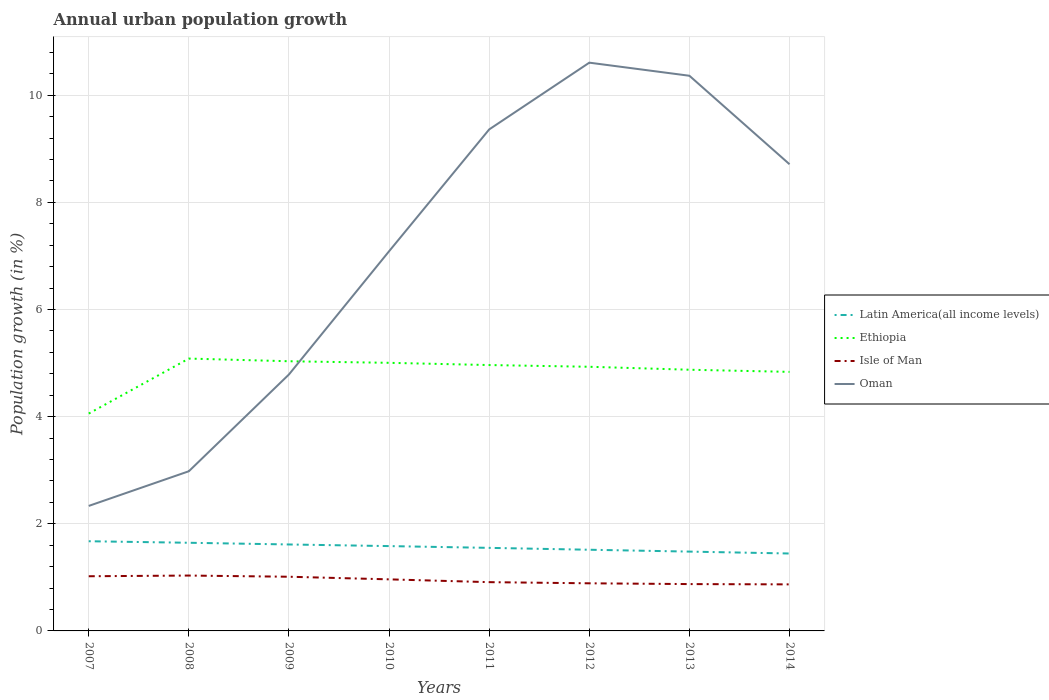Across all years, what is the maximum percentage of urban population growth in Oman?
Offer a very short reply. 2.33. In which year was the percentage of urban population growth in Oman maximum?
Provide a succinct answer. 2007. What is the total percentage of urban population growth in Oman in the graph?
Provide a succinct answer. -4.11. What is the difference between the highest and the second highest percentage of urban population growth in Ethiopia?
Your answer should be very brief. 1.03. What is the difference between the highest and the lowest percentage of urban population growth in Oman?
Offer a very short reply. 5. How many years are there in the graph?
Keep it short and to the point. 8. Are the values on the major ticks of Y-axis written in scientific E-notation?
Ensure brevity in your answer.  No. Does the graph contain any zero values?
Offer a terse response. No. Does the graph contain grids?
Provide a succinct answer. Yes. Where does the legend appear in the graph?
Offer a terse response. Center right. How many legend labels are there?
Give a very brief answer. 4. How are the legend labels stacked?
Give a very brief answer. Vertical. What is the title of the graph?
Ensure brevity in your answer.  Annual urban population growth. What is the label or title of the X-axis?
Your answer should be compact. Years. What is the label or title of the Y-axis?
Provide a succinct answer. Population growth (in %). What is the Population growth (in %) in Latin America(all income levels) in 2007?
Keep it short and to the point. 1.67. What is the Population growth (in %) in Ethiopia in 2007?
Your answer should be very brief. 4.06. What is the Population growth (in %) of Isle of Man in 2007?
Make the answer very short. 1.02. What is the Population growth (in %) of Oman in 2007?
Your response must be concise. 2.33. What is the Population growth (in %) in Latin America(all income levels) in 2008?
Make the answer very short. 1.65. What is the Population growth (in %) in Ethiopia in 2008?
Your answer should be compact. 5.08. What is the Population growth (in %) of Isle of Man in 2008?
Offer a very short reply. 1.03. What is the Population growth (in %) of Oman in 2008?
Offer a terse response. 2.98. What is the Population growth (in %) of Latin America(all income levels) in 2009?
Ensure brevity in your answer.  1.61. What is the Population growth (in %) of Ethiopia in 2009?
Provide a short and direct response. 5.03. What is the Population growth (in %) of Isle of Man in 2009?
Your answer should be very brief. 1.01. What is the Population growth (in %) in Oman in 2009?
Keep it short and to the point. 4.79. What is the Population growth (in %) of Latin America(all income levels) in 2010?
Provide a succinct answer. 1.58. What is the Population growth (in %) in Ethiopia in 2010?
Ensure brevity in your answer.  5. What is the Population growth (in %) of Isle of Man in 2010?
Provide a short and direct response. 0.96. What is the Population growth (in %) of Oman in 2010?
Keep it short and to the point. 7.09. What is the Population growth (in %) of Latin America(all income levels) in 2011?
Your response must be concise. 1.55. What is the Population growth (in %) of Ethiopia in 2011?
Your answer should be compact. 4.96. What is the Population growth (in %) of Isle of Man in 2011?
Your answer should be compact. 0.91. What is the Population growth (in %) in Oman in 2011?
Provide a succinct answer. 9.36. What is the Population growth (in %) in Latin America(all income levels) in 2012?
Your answer should be compact. 1.52. What is the Population growth (in %) of Ethiopia in 2012?
Provide a succinct answer. 4.93. What is the Population growth (in %) of Isle of Man in 2012?
Keep it short and to the point. 0.89. What is the Population growth (in %) in Oman in 2012?
Give a very brief answer. 10.61. What is the Population growth (in %) in Latin America(all income levels) in 2013?
Your response must be concise. 1.48. What is the Population growth (in %) of Ethiopia in 2013?
Ensure brevity in your answer.  4.88. What is the Population growth (in %) of Isle of Man in 2013?
Your answer should be compact. 0.87. What is the Population growth (in %) of Oman in 2013?
Keep it short and to the point. 10.36. What is the Population growth (in %) of Latin America(all income levels) in 2014?
Provide a short and direct response. 1.45. What is the Population growth (in %) in Ethiopia in 2014?
Provide a short and direct response. 4.84. What is the Population growth (in %) of Isle of Man in 2014?
Your answer should be compact. 0.87. What is the Population growth (in %) of Oman in 2014?
Keep it short and to the point. 8.71. Across all years, what is the maximum Population growth (in %) of Latin America(all income levels)?
Give a very brief answer. 1.67. Across all years, what is the maximum Population growth (in %) of Ethiopia?
Ensure brevity in your answer.  5.08. Across all years, what is the maximum Population growth (in %) in Isle of Man?
Provide a short and direct response. 1.03. Across all years, what is the maximum Population growth (in %) of Oman?
Offer a very short reply. 10.61. Across all years, what is the minimum Population growth (in %) in Latin America(all income levels)?
Your answer should be compact. 1.45. Across all years, what is the minimum Population growth (in %) of Ethiopia?
Your response must be concise. 4.06. Across all years, what is the minimum Population growth (in %) of Isle of Man?
Your answer should be compact. 0.87. Across all years, what is the minimum Population growth (in %) of Oman?
Offer a terse response. 2.33. What is the total Population growth (in %) in Latin America(all income levels) in the graph?
Your response must be concise. 12.51. What is the total Population growth (in %) in Ethiopia in the graph?
Your answer should be compact. 38.78. What is the total Population growth (in %) of Isle of Man in the graph?
Provide a succinct answer. 7.57. What is the total Population growth (in %) in Oman in the graph?
Keep it short and to the point. 56.23. What is the difference between the Population growth (in %) in Latin America(all income levels) in 2007 and that in 2008?
Your response must be concise. 0.03. What is the difference between the Population growth (in %) in Ethiopia in 2007 and that in 2008?
Give a very brief answer. -1.03. What is the difference between the Population growth (in %) in Isle of Man in 2007 and that in 2008?
Give a very brief answer. -0.01. What is the difference between the Population growth (in %) of Oman in 2007 and that in 2008?
Keep it short and to the point. -0.65. What is the difference between the Population growth (in %) in Latin America(all income levels) in 2007 and that in 2009?
Keep it short and to the point. 0.06. What is the difference between the Population growth (in %) of Ethiopia in 2007 and that in 2009?
Keep it short and to the point. -0.98. What is the difference between the Population growth (in %) in Isle of Man in 2007 and that in 2009?
Your answer should be very brief. 0.01. What is the difference between the Population growth (in %) in Oman in 2007 and that in 2009?
Provide a succinct answer. -2.45. What is the difference between the Population growth (in %) of Latin America(all income levels) in 2007 and that in 2010?
Your response must be concise. 0.09. What is the difference between the Population growth (in %) in Ethiopia in 2007 and that in 2010?
Your answer should be compact. -0.95. What is the difference between the Population growth (in %) of Isle of Man in 2007 and that in 2010?
Provide a short and direct response. 0.06. What is the difference between the Population growth (in %) of Oman in 2007 and that in 2010?
Your response must be concise. -4.75. What is the difference between the Population growth (in %) of Latin America(all income levels) in 2007 and that in 2011?
Offer a very short reply. 0.12. What is the difference between the Population growth (in %) in Ethiopia in 2007 and that in 2011?
Offer a terse response. -0.91. What is the difference between the Population growth (in %) of Isle of Man in 2007 and that in 2011?
Offer a very short reply. 0.11. What is the difference between the Population growth (in %) of Oman in 2007 and that in 2011?
Your answer should be compact. -7.03. What is the difference between the Population growth (in %) in Latin America(all income levels) in 2007 and that in 2012?
Ensure brevity in your answer.  0.16. What is the difference between the Population growth (in %) in Ethiopia in 2007 and that in 2012?
Offer a terse response. -0.87. What is the difference between the Population growth (in %) of Isle of Man in 2007 and that in 2012?
Keep it short and to the point. 0.13. What is the difference between the Population growth (in %) of Oman in 2007 and that in 2012?
Your response must be concise. -8.27. What is the difference between the Population growth (in %) of Latin America(all income levels) in 2007 and that in 2013?
Offer a terse response. 0.19. What is the difference between the Population growth (in %) in Ethiopia in 2007 and that in 2013?
Your answer should be very brief. -0.82. What is the difference between the Population growth (in %) in Isle of Man in 2007 and that in 2013?
Give a very brief answer. 0.15. What is the difference between the Population growth (in %) in Oman in 2007 and that in 2013?
Offer a very short reply. -8.03. What is the difference between the Population growth (in %) in Latin America(all income levels) in 2007 and that in 2014?
Make the answer very short. 0.23. What is the difference between the Population growth (in %) in Ethiopia in 2007 and that in 2014?
Offer a terse response. -0.78. What is the difference between the Population growth (in %) in Isle of Man in 2007 and that in 2014?
Make the answer very short. 0.15. What is the difference between the Population growth (in %) of Oman in 2007 and that in 2014?
Provide a short and direct response. -6.38. What is the difference between the Population growth (in %) in Latin America(all income levels) in 2008 and that in 2009?
Provide a short and direct response. 0.03. What is the difference between the Population growth (in %) of Isle of Man in 2008 and that in 2009?
Offer a terse response. 0.02. What is the difference between the Population growth (in %) in Oman in 2008 and that in 2009?
Ensure brevity in your answer.  -1.81. What is the difference between the Population growth (in %) in Latin America(all income levels) in 2008 and that in 2010?
Your answer should be compact. 0.06. What is the difference between the Population growth (in %) in Ethiopia in 2008 and that in 2010?
Provide a short and direct response. 0.08. What is the difference between the Population growth (in %) in Isle of Man in 2008 and that in 2010?
Provide a succinct answer. 0.07. What is the difference between the Population growth (in %) in Oman in 2008 and that in 2010?
Provide a short and direct response. -4.11. What is the difference between the Population growth (in %) of Latin America(all income levels) in 2008 and that in 2011?
Give a very brief answer. 0.1. What is the difference between the Population growth (in %) of Ethiopia in 2008 and that in 2011?
Your answer should be compact. 0.12. What is the difference between the Population growth (in %) of Isle of Man in 2008 and that in 2011?
Offer a very short reply. 0.12. What is the difference between the Population growth (in %) of Oman in 2008 and that in 2011?
Your answer should be compact. -6.38. What is the difference between the Population growth (in %) of Latin America(all income levels) in 2008 and that in 2012?
Your answer should be compact. 0.13. What is the difference between the Population growth (in %) in Ethiopia in 2008 and that in 2012?
Provide a short and direct response. 0.15. What is the difference between the Population growth (in %) of Isle of Man in 2008 and that in 2012?
Your response must be concise. 0.14. What is the difference between the Population growth (in %) of Oman in 2008 and that in 2012?
Offer a terse response. -7.63. What is the difference between the Population growth (in %) in Latin America(all income levels) in 2008 and that in 2013?
Your answer should be very brief. 0.16. What is the difference between the Population growth (in %) in Ethiopia in 2008 and that in 2013?
Offer a very short reply. 0.21. What is the difference between the Population growth (in %) of Isle of Man in 2008 and that in 2013?
Your answer should be very brief. 0.16. What is the difference between the Population growth (in %) in Oman in 2008 and that in 2013?
Ensure brevity in your answer.  -7.38. What is the difference between the Population growth (in %) in Latin America(all income levels) in 2008 and that in 2014?
Give a very brief answer. 0.2. What is the difference between the Population growth (in %) in Ethiopia in 2008 and that in 2014?
Make the answer very short. 0.25. What is the difference between the Population growth (in %) in Isle of Man in 2008 and that in 2014?
Give a very brief answer. 0.16. What is the difference between the Population growth (in %) of Oman in 2008 and that in 2014?
Offer a terse response. -5.73. What is the difference between the Population growth (in %) in Latin America(all income levels) in 2009 and that in 2010?
Keep it short and to the point. 0.03. What is the difference between the Population growth (in %) in Ethiopia in 2009 and that in 2010?
Offer a very short reply. 0.03. What is the difference between the Population growth (in %) of Isle of Man in 2009 and that in 2010?
Give a very brief answer. 0.05. What is the difference between the Population growth (in %) of Oman in 2009 and that in 2010?
Your answer should be compact. -2.3. What is the difference between the Population growth (in %) in Latin America(all income levels) in 2009 and that in 2011?
Make the answer very short. 0.06. What is the difference between the Population growth (in %) in Ethiopia in 2009 and that in 2011?
Provide a succinct answer. 0.07. What is the difference between the Population growth (in %) of Isle of Man in 2009 and that in 2011?
Ensure brevity in your answer.  0.1. What is the difference between the Population growth (in %) of Oman in 2009 and that in 2011?
Keep it short and to the point. -4.57. What is the difference between the Population growth (in %) in Latin America(all income levels) in 2009 and that in 2012?
Provide a short and direct response. 0.1. What is the difference between the Population growth (in %) in Ethiopia in 2009 and that in 2012?
Provide a short and direct response. 0.1. What is the difference between the Population growth (in %) of Isle of Man in 2009 and that in 2012?
Keep it short and to the point. 0.12. What is the difference between the Population growth (in %) in Oman in 2009 and that in 2012?
Ensure brevity in your answer.  -5.82. What is the difference between the Population growth (in %) of Latin America(all income levels) in 2009 and that in 2013?
Provide a short and direct response. 0.13. What is the difference between the Population growth (in %) of Ethiopia in 2009 and that in 2013?
Keep it short and to the point. 0.16. What is the difference between the Population growth (in %) of Isle of Man in 2009 and that in 2013?
Your response must be concise. 0.14. What is the difference between the Population growth (in %) in Oman in 2009 and that in 2013?
Your response must be concise. -5.58. What is the difference between the Population growth (in %) in Latin America(all income levels) in 2009 and that in 2014?
Ensure brevity in your answer.  0.17. What is the difference between the Population growth (in %) of Ethiopia in 2009 and that in 2014?
Your answer should be compact. 0.2. What is the difference between the Population growth (in %) in Isle of Man in 2009 and that in 2014?
Offer a very short reply. 0.14. What is the difference between the Population growth (in %) in Oman in 2009 and that in 2014?
Keep it short and to the point. -3.92. What is the difference between the Population growth (in %) in Latin America(all income levels) in 2010 and that in 2011?
Your answer should be very brief. 0.03. What is the difference between the Population growth (in %) in Ethiopia in 2010 and that in 2011?
Offer a terse response. 0.04. What is the difference between the Population growth (in %) in Isle of Man in 2010 and that in 2011?
Offer a very short reply. 0.05. What is the difference between the Population growth (in %) of Oman in 2010 and that in 2011?
Offer a terse response. -2.27. What is the difference between the Population growth (in %) in Latin America(all income levels) in 2010 and that in 2012?
Provide a short and direct response. 0.07. What is the difference between the Population growth (in %) of Ethiopia in 2010 and that in 2012?
Provide a succinct answer. 0.07. What is the difference between the Population growth (in %) of Isle of Man in 2010 and that in 2012?
Keep it short and to the point. 0.07. What is the difference between the Population growth (in %) in Oman in 2010 and that in 2012?
Provide a short and direct response. -3.52. What is the difference between the Population growth (in %) of Latin America(all income levels) in 2010 and that in 2013?
Give a very brief answer. 0.1. What is the difference between the Population growth (in %) in Ethiopia in 2010 and that in 2013?
Provide a succinct answer. 0.13. What is the difference between the Population growth (in %) of Isle of Man in 2010 and that in 2013?
Your response must be concise. 0.09. What is the difference between the Population growth (in %) in Oman in 2010 and that in 2013?
Offer a very short reply. -3.28. What is the difference between the Population growth (in %) in Latin America(all income levels) in 2010 and that in 2014?
Offer a very short reply. 0.14. What is the difference between the Population growth (in %) of Ethiopia in 2010 and that in 2014?
Offer a very short reply. 0.17. What is the difference between the Population growth (in %) of Isle of Man in 2010 and that in 2014?
Ensure brevity in your answer.  0.09. What is the difference between the Population growth (in %) of Oman in 2010 and that in 2014?
Make the answer very short. -1.62. What is the difference between the Population growth (in %) of Latin America(all income levels) in 2011 and that in 2012?
Give a very brief answer. 0.04. What is the difference between the Population growth (in %) in Ethiopia in 2011 and that in 2012?
Ensure brevity in your answer.  0.03. What is the difference between the Population growth (in %) of Isle of Man in 2011 and that in 2012?
Provide a short and direct response. 0.02. What is the difference between the Population growth (in %) of Oman in 2011 and that in 2012?
Provide a short and direct response. -1.25. What is the difference between the Population growth (in %) in Latin America(all income levels) in 2011 and that in 2013?
Make the answer very short. 0.07. What is the difference between the Population growth (in %) of Ethiopia in 2011 and that in 2013?
Your response must be concise. 0.09. What is the difference between the Population growth (in %) in Isle of Man in 2011 and that in 2013?
Ensure brevity in your answer.  0.04. What is the difference between the Population growth (in %) in Oman in 2011 and that in 2013?
Give a very brief answer. -1. What is the difference between the Population growth (in %) of Latin America(all income levels) in 2011 and that in 2014?
Ensure brevity in your answer.  0.11. What is the difference between the Population growth (in %) in Ethiopia in 2011 and that in 2014?
Provide a short and direct response. 0.13. What is the difference between the Population growth (in %) of Isle of Man in 2011 and that in 2014?
Your answer should be very brief. 0.04. What is the difference between the Population growth (in %) of Oman in 2011 and that in 2014?
Ensure brevity in your answer.  0.65. What is the difference between the Population growth (in %) in Latin America(all income levels) in 2012 and that in 2013?
Offer a very short reply. 0.03. What is the difference between the Population growth (in %) in Ethiopia in 2012 and that in 2013?
Offer a very short reply. 0.06. What is the difference between the Population growth (in %) of Isle of Man in 2012 and that in 2013?
Offer a very short reply. 0.01. What is the difference between the Population growth (in %) in Oman in 2012 and that in 2013?
Offer a very short reply. 0.24. What is the difference between the Population growth (in %) in Latin America(all income levels) in 2012 and that in 2014?
Your response must be concise. 0.07. What is the difference between the Population growth (in %) in Ethiopia in 2012 and that in 2014?
Offer a terse response. 0.1. What is the difference between the Population growth (in %) in Isle of Man in 2012 and that in 2014?
Ensure brevity in your answer.  0.02. What is the difference between the Population growth (in %) of Oman in 2012 and that in 2014?
Give a very brief answer. 1.9. What is the difference between the Population growth (in %) of Latin America(all income levels) in 2013 and that in 2014?
Ensure brevity in your answer.  0.04. What is the difference between the Population growth (in %) of Ethiopia in 2013 and that in 2014?
Offer a terse response. 0.04. What is the difference between the Population growth (in %) in Isle of Man in 2013 and that in 2014?
Your response must be concise. 0.01. What is the difference between the Population growth (in %) in Oman in 2013 and that in 2014?
Give a very brief answer. 1.65. What is the difference between the Population growth (in %) in Latin America(all income levels) in 2007 and the Population growth (in %) in Ethiopia in 2008?
Give a very brief answer. -3.41. What is the difference between the Population growth (in %) of Latin America(all income levels) in 2007 and the Population growth (in %) of Isle of Man in 2008?
Your answer should be very brief. 0.64. What is the difference between the Population growth (in %) in Latin America(all income levels) in 2007 and the Population growth (in %) in Oman in 2008?
Offer a terse response. -1.31. What is the difference between the Population growth (in %) in Ethiopia in 2007 and the Population growth (in %) in Isle of Man in 2008?
Your answer should be compact. 3.02. What is the difference between the Population growth (in %) in Ethiopia in 2007 and the Population growth (in %) in Oman in 2008?
Give a very brief answer. 1.08. What is the difference between the Population growth (in %) of Isle of Man in 2007 and the Population growth (in %) of Oman in 2008?
Offer a terse response. -1.96. What is the difference between the Population growth (in %) in Latin America(all income levels) in 2007 and the Population growth (in %) in Ethiopia in 2009?
Your response must be concise. -3.36. What is the difference between the Population growth (in %) of Latin America(all income levels) in 2007 and the Population growth (in %) of Isle of Man in 2009?
Give a very brief answer. 0.66. What is the difference between the Population growth (in %) in Latin America(all income levels) in 2007 and the Population growth (in %) in Oman in 2009?
Your answer should be compact. -3.11. What is the difference between the Population growth (in %) of Ethiopia in 2007 and the Population growth (in %) of Isle of Man in 2009?
Provide a succinct answer. 3.05. What is the difference between the Population growth (in %) of Ethiopia in 2007 and the Population growth (in %) of Oman in 2009?
Offer a very short reply. -0.73. What is the difference between the Population growth (in %) of Isle of Man in 2007 and the Population growth (in %) of Oman in 2009?
Your answer should be very brief. -3.77. What is the difference between the Population growth (in %) in Latin America(all income levels) in 2007 and the Population growth (in %) in Ethiopia in 2010?
Keep it short and to the point. -3.33. What is the difference between the Population growth (in %) in Latin America(all income levels) in 2007 and the Population growth (in %) in Isle of Man in 2010?
Your response must be concise. 0.71. What is the difference between the Population growth (in %) in Latin America(all income levels) in 2007 and the Population growth (in %) in Oman in 2010?
Offer a terse response. -5.41. What is the difference between the Population growth (in %) in Ethiopia in 2007 and the Population growth (in %) in Isle of Man in 2010?
Provide a short and direct response. 3.09. What is the difference between the Population growth (in %) in Ethiopia in 2007 and the Population growth (in %) in Oman in 2010?
Your answer should be very brief. -3.03. What is the difference between the Population growth (in %) of Isle of Man in 2007 and the Population growth (in %) of Oman in 2010?
Make the answer very short. -6.07. What is the difference between the Population growth (in %) of Latin America(all income levels) in 2007 and the Population growth (in %) of Ethiopia in 2011?
Offer a terse response. -3.29. What is the difference between the Population growth (in %) in Latin America(all income levels) in 2007 and the Population growth (in %) in Isle of Man in 2011?
Your answer should be very brief. 0.76. What is the difference between the Population growth (in %) in Latin America(all income levels) in 2007 and the Population growth (in %) in Oman in 2011?
Provide a short and direct response. -7.69. What is the difference between the Population growth (in %) of Ethiopia in 2007 and the Population growth (in %) of Isle of Man in 2011?
Your response must be concise. 3.15. What is the difference between the Population growth (in %) in Ethiopia in 2007 and the Population growth (in %) in Oman in 2011?
Keep it short and to the point. -5.3. What is the difference between the Population growth (in %) in Isle of Man in 2007 and the Population growth (in %) in Oman in 2011?
Your response must be concise. -8.34. What is the difference between the Population growth (in %) of Latin America(all income levels) in 2007 and the Population growth (in %) of Ethiopia in 2012?
Provide a short and direct response. -3.26. What is the difference between the Population growth (in %) in Latin America(all income levels) in 2007 and the Population growth (in %) in Isle of Man in 2012?
Offer a terse response. 0.79. What is the difference between the Population growth (in %) of Latin America(all income levels) in 2007 and the Population growth (in %) of Oman in 2012?
Give a very brief answer. -8.93. What is the difference between the Population growth (in %) of Ethiopia in 2007 and the Population growth (in %) of Isle of Man in 2012?
Offer a very short reply. 3.17. What is the difference between the Population growth (in %) of Ethiopia in 2007 and the Population growth (in %) of Oman in 2012?
Offer a terse response. -6.55. What is the difference between the Population growth (in %) of Isle of Man in 2007 and the Population growth (in %) of Oman in 2012?
Provide a short and direct response. -9.59. What is the difference between the Population growth (in %) of Latin America(all income levels) in 2007 and the Population growth (in %) of Ethiopia in 2013?
Offer a terse response. -3.2. What is the difference between the Population growth (in %) in Latin America(all income levels) in 2007 and the Population growth (in %) in Isle of Man in 2013?
Keep it short and to the point. 0.8. What is the difference between the Population growth (in %) of Latin America(all income levels) in 2007 and the Population growth (in %) of Oman in 2013?
Your answer should be compact. -8.69. What is the difference between the Population growth (in %) of Ethiopia in 2007 and the Population growth (in %) of Isle of Man in 2013?
Make the answer very short. 3.18. What is the difference between the Population growth (in %) of Ethiopia in 2007 and the Population growth (in %) of Oman in 2013?
Make the answer very short. -6.31. What is the difference between the Population growth (in %) in Isle of Man in 2007 and the Population growth (in %) in Oman in 2013?
Provide a succinct answer. -9.34. What is the difference between the Population growth (in %) of Latin America(all income levels) in 2007 and the Population growth (in %) of Ethiopia in 2014?
Ensure brevity in your answer.  -3.16. What is the difference between the Population growth (in %) of Latin America(all income levels) in 2007 and the Population growth (in %) of Isle of Man in 2014?
Your answer should be compact. 0.81. What is the difference between the Population growth (in %) of Latin America(all income levels) in 2007 and the Population growth (in %) of Oman in 2014?
Provide a short and direct response. -7.04. What is the difference between the Population growth (in %) of Ethiopia in 2007 and the Population growth (in %) of Isle of Man in 2014?
Give a very brief answer. 3.19. What is the difference between the Population growth (in %) of Ethiopia in 2007 and the Population growth (in %) of Oman in 2014?
Offer a very short reply. -4.65. What is the difference between the Population growth (in %) of Isle of Man in 2007 and the Population growth (in %) of Oman in 2014?
Provide a short and direct response. -7.69. What is the difference between the Population growth (in %) of Latin America(all income levels) in 2008 and the Population growth (in %) of Ethiopia in 2009?
Ensure brevity in your answer.  -3.39. What is the difference between the Population growth (in %) of Latin America(all income levels) in 2008 and the Population growth (in %) of Isle of Man in 2009?
Make the answer very short. 0.63. What is the difference between the Population growth (in %) in Latin America(all income levels) in 2008 and the Population growth (in %) in Oman in 2009?
Ensure brevity in your answer.  -3.14. What is the difference between the Population growth (in %) of Ethiopia in 2008 and the Population growth (in %) of Isle of Man in 2009?
Your answer should be very brief. 4.07. What is the difference between the Population growth (in %) of Ethiopia in 2008 and the Population growth (in %) of Oman in 2009?
Make the answer very short. 0.3. What is the difference between the Population growth (in %) in Isle of Man in 2008 and the Population growth (in %) in Oman in 2009?
Keep it short and to the point. -3.75. What is the difference between the Population growth (in %) of Latin America(all income levels) in 2008 and the Population growth (in %) of Ethiopia in 2010?
Keep it short and to the point. -3.36. What is the difference between the Population growth (in %) of Latin America(all income levels) in 2008 and the Population growth (in %) of Isle of Man in 2010?
Keep it short and to the point. 0.68. What is the difference between the Population growth (in %) of Latin America(all income levels) in 2008 and the Population growth (in %) of Oman in 2010?
Keep it short and to the point. -5.44. What is the difference between the Population growth (in %) in Ethiopia in 2008 and the Population growth (in %) in Isle of Man in 2010?
Keep it short and to the point. 4.12. What is the difference between the Population growth (in %) in Ethiopia in 2008 and the Population growth (in %) in Oman in 2010?
Give a very brief answer. -2. What is the difference between the Population growth (in %) in Isle of Man in 2008 and the Population growth (in %) in Oman in 2010?
Offer a terse response. -6.05. What is the difference between the Population growth (in %) of Latin America(all income levels) in 2008 and the Population growth (in %) of Ethiopia in 2011?
Offer a terse response. -3.32. What is the difference between the Population growth (in %) in Latin America(all income levels) in 2008 and the Population growth (in %) in Isle of Man in 2011?
Ensure brevity in your answer.  0.74. What is the difference between the Population growth (in %) in Latin America(all income levels) in 2008 and the Population growth (in %) in Oman in 2011?
Provide a short and direct response. -7.72. What is the difference between the Population growth (in %) of Ethiopia in 2008 and the Population growth (in %) of Isle of Man in 2011?
Offer a terse response. 4.17. What is the difference between the Population growth (in %) of Ethiopia in 2008 and the Population growth (in %) of Oman in 2011?
Keep it short and to the point. -4.28. What is the difference between the Population growth (in %) of Isle of Man in 2008 and the Population growth (in %) of Oman in 2011?
Offer a terse response. -8.33. What is the difference between the Population growth (in %) of Latin America(all income levels) in 2008 and the Population growth (in %) of Ethiopia in 2012?
Offer a terse response. -3.29. What is the difference between the Population growth (in %) in Latin America(all income levels) in 2008 and the Population growth (in %) in Isle of Man in 2012?
Make the answer very short. 0.76. What is the difference between the Population growth (in %) of Latin America(all income levels) in 2008 and the Population growth (in %) of Oman in 2012?
Offer a very short reply. -8.96. What is the difference between the Population growth (in %) of Ethiopia in 2008 and the Population growth (in %) of Isle of Man in 2012?
Offer a very short reply. 4.2. What is the difference between the Population growth (in %) in Ethiopia in 2008 and the Population growth (in %) in Oman in 2012?
Offer a terse response. -5.52. What is the difference between the Population growth (in %) of Isle of Man in 2008 and the Population growth (in %) of Oman in 2012?
Ensure brevity in your answer.  -9.57. What is the difference between the Population growth (in %) of Latin America(all income levels) in 2008 and the Population growth (in %) of Ethiopia in 2013?
Your answer should be compact. -3.23. What is the difference between the Population growth (in %) in Latin America(all income levels) in 2008 and the Population growth (in %) in Isle of Man in 2013?
Make the answer very short. 0.77. What is the difference between the Population growth (in %) of Latin America(all income levels) in 2008 and the Population growth (in %) of Oman in 2013?
Provide a short and direct response. -8.72. What is the difference between the Population growth (in %) of Ethiopia in 2008 and the Population growth (in %) of Isle of Man in 2013?
Give a very brief answer. 4.21. What is the difference between the Population growth (in %) of Ethiopia in 2008 and the Population growth (in %) of Oman in 2013?
Offer a terse response. -5.28. What is the difference between the Population growth (in %) in Isle of Man in 2008 and the Population growth (in %) in Oman in 2013?
Offer a very short reply. -9.33. What is the difference between the Population growth (in %) of Latin America(all income levels) in 2008 and the Population growth (in %) of Ethiopia in 2014?
Your answer should be compact. -3.19. What is the difference between the Population growth (in %) in Latin America(all income levels) in 2008 and the Population growth (in %) in Isle of Man in 2014?
Your answer should be very brief. 0.78. What is the difference between the Population growth (in %) of Latin America(all income levels) in 2008 and the Population growth (in %) of Oman in 2014?
Make the answer very short. -7.07. What is the difference between the Population growth (in %) of Ethiopia in 2008 and the Population growth (in %) of Isle of Man in 2014?
Offer a very short reply. 4.21. What is the difference between the Population growth (in %) in Ethiopia in 2008 and the Population growth (in %) in Oman in 2014?
Provide a short and direct response. -3.63. What is the difference between the Population growth (in %) of Isle of Man in 2008 and the Population growth (in %) of Oman in 2014?
Keep it short and to the point. -7.68. What is the difference between the Population growth (in %) in Latin America(all income levels) in 2009 and the Population growth (in %) in Ethiopia in 2010?
Your response must be concise. -3.39. What is the difference between the Population growth (in %) in Latin America(all income levels) in 2009 and the Population growth (in %) in Isle of Man in 2010?
Provide a short and direct response. 0.65. What is the difference between the Population growth (in %) in Latin America(all income levels) in 2009 and the Population growth (in %) in Oman in 2010?
Your answer should be compact. -5.47. What is the difference between the Population growth (in %) of Ethiopia in 2009 and the Population growth (in %) of Isle of Man in 2010?
Offer a terse response. 4.07. What is the difference between the Population growth (in %) in Ethiopia in 2009 and the Population growth (in %) in Oman in 2010?
Offer a very short reply. -2.05. What is the difference between the Population growth (in %) in Isle of Man in 2009 and the Population growth (in %) in Oman in 2010?
Offer a very short reply. -6.08. What is the difference between the Population growth (in %) of Latin America(all income levels) in 2009 and the Population growth (in %) of Ethiopia in 2011?
Give a very brief answer. -3.35. What is the difference between the Population growth (in %) in Latin America(all income levels) in 2009 and the Population growth (in %) in Isle of Man in 2011?
Provide a short and direct response. 0.7. What is the difference between the Population growth (in %) in Latin America(all income levels) in 2009 and the Population growth (in %) in Oman in 2011?
Your answer should be very brief. -7.75. What is the difference between the Population growth (in %) in Ethiopia in 2009 and the Population growth (in %) in Isle of Man in 2011?
Offer a terse response. 4.12. What is the difference between the Population growth (in %) of Ethiopia in 2009 and the Population growth (in %) of Oman in 2011?
Ensure brevity in your answer.  -4.33. What is the difference between the Population growth (in %) of Isle of Man in 2009 and the Population growth (in %) of Oman in 2011?
Provide a short and direct response. -8.35. What is the difference between the Population growth (in %) of Latin America(all income levels) in 2009 and the Population growth (in %) of Ethiopia in 2012?
Your answer should be very brief. -3.32. What is the difference between the Population growth (in %) in Latin America(all income levels) in 2009 and the Population growth (in %) in Isle of Man in 2012?
Ensure brevity in your answer.  0.73. What is the difference between the Population growth (in %) in Latin America(all income levels) in 2009 and the Population growth (in %) in Oman in 2012?
Ensure brevity in your answer.  -8.99. What is the difference between the Population growth (in %) in Ethiopia in 2009 and the Population growth (in %) in Isle of Man in 2012?
Provide a short and direct response. 4.15. What is the difference between the Population growth (in %) of Ethiopia in 2009 and the Population growth (in %) of Oman in 2012?
Provide a succinct answer. -5.57. What is the difference between the Population growth (in %) of Isle of Man in 2009 and the Population growth (in %) of Oman in 2012?
Your answer should be very brief. -9.6. What is the difference between the Population growth (in %) in Latin America(all income levels) in 2009 and the Population growth (in %) in Ethiopia in 2013?
Ensure brevity in your answer.  -3.26. What is the difference between the Population growth (in %) of Latin America(all income levels) in 2009 and the Population growth (in %) of Isle of Man in 2013?
Offer a terse response. 0.74. What is the difference between the Population growth (in %) of Latin America(all income levels) in 2009 and the Population growth (in %) of Oman in 2013?
Provide a short and direct response. -8.75. What is the difference between the Population growth (in %) in Ethiopia in 2009 and the Population growth (in %) in Isle of Man in 2013?
Ensure brevity in your answer.  4.16. What is the difference between the Population growth (in %) of Ethiopia in 2009 and the Population growth (in %) of Oman in 2013?
Your answer should be very brief. -5.33. What is the difference between the Population growth (in %) in Isle of Man in 2009 and the Population growth (in %) in Oman in 2013?
Offer a very short reply. -9.35. What is the difference between the Population growth (in %) in Latin America(all income levels) in 2009 and the Population growth (in %) in Ethiopia in 2014?
Give a very brief answer. -3.22. What is the difference between the Population growth (in %) of Latin America(all income levels) in 2009 and the Population growth (in %) of Isle of Man in 2014?
Give a very brief answer. 0.74. What is the difference between the Population growth (in %) in Latin America(all income levels) in 2009 and the Population growth (in %) in Oman in 2014?
Your answer should be very brief. -7.1. What is the difference between the Population growth (in %) in Ethiopia in 2009 and the Population growth (in %) in Isle of Man in 2014?
Offer a terse response. 4.17. What is the difference between the Population growth (in %) in Ethiopia in 2009 and the Population growth (in %) in Oman in 2014?
Keep it short and to the point. -3.68. What is the difference between the Population growth (in %) of Isle of Man in 2009 and the Population growth (in %) of Oman in 2014?
Offer a very short reply. -7.7. What is the difference between the Population growth (in %) in Latin America(all income levels) in 2010 and the Population growth (in %) in Ethiopia in 2011?
Provide a short and direct response. -3.38. What is the difference between the Population growth (in %) in Latin America(all income levels) in 2010 and the Population growth (in %) in Isle of Man in 2011?
Your response must be concise. 0.67. What is the difference between the Population growth (in %) in Latin America(all income levels) in 2010 and the Population growth (in %) in Oman in 2011?
Provide a short and direct response. -7.78. What is the difference between the Population growth (in %) in Ethiopia in 2010 and the Population growth (in %) in Isle of Man in 2011?
Provide a succinct answer. 4.09. What is the difference between the Population growth (in %) of Ethiopia in 2010 and the Population growth (in %) of Oman in 2011?
Provide a short and direct response. -4.36. What is the difference between the Population growth (in %) in Isle of Man in 2010 and the Population growth (in %) in Oman in 2011?
Your answer should be very brief. -8.4. What is the difference between the Population growth (in %) in Latin America(all income levels) in 2010 and the Population growth (in %) in Ethiopia in 2012?
Provide a short and direct response. -3.35. What is the difference between the Population growth (in %) of Latin America(all income levels) in 2010 and the Population growth (in %) of Isle of Man in 2012?
Your answer should be very brief. 0.69. What is the difference between the Population growth (in %) of Latin America(all income levels) in 2010 and the Population growth (in %) of Oman in 2012?
Provide a short and direct response. -9.02. What is the difference between the Population growth (in %) in Ethiopia in 2010 and the Population growth (in %) in Isle of Man in 2012?
Provide a short and direct response. 4.12. What is the difference between the Population growth (in %) of Ethiopia in 2010 and the Population growth (in %) of Oman in 2012?
Make the answer very short. -5.6. What is the difference between the Population growth (in %) in Isle of Man in 2010 and the Population growth (in %) in Oman in 2012?
Make the answer very short. -9.64. What is the difference between the Population growth (in %) of Latin America(all income levels) in 2010 and the Population growth (in %) of Ethiopia in 2013?
Ensure brevity in your answer.  -3.29. What is the difference between the Population growth (in %) in Latin America(all income levels) in 2010 and the Population growth (in %) in Isle of Man in 2013?
Keep it short and to the point. 0.71. What is the difference between the Population growth (in %) of Latin America(all income levels) in 2010 and the Population growth (in %) of Oman in 2013?
Provide a succinct answer. -8.78. What is the difference between the Population growth (in %) of Ethiopia in 2010 and the Population growth (in %) of Isle of Man in 2013?
Your response must be concise. 4.13. What is the difference between the Population growth (in %) in Ethiopia in 2010 and the Population growth (in %) in Oman in 2013?
Your answer should be very brief. -5.36. What is the difference between the Population growth (in %) in Isle of Man in 2010 and the Population growth (in %) in Oman in 2013?
Your response must be concise. -9.4. What is the difference between the Population growth (in %) in Latin America(all income levels) in 2010 and the Population growth (in %) in Ethiopia in 2014?
Offer a terse response. -3.25. What is the difference between the Population growth (in %) of Latin America(all income levels) in 2010 and the Population growth (in %) of Isle of Man in 2014?
Make the answer very short. 0.71. What is the difference between the Population growth (in %) of Latin America(all income levels) in 2010 and the Population growth (in %) of Oman in 2014?
Provide a succinct answer. -7.13. What is the difference between the Population growth (in %) in Ethiopia in 2010 and the Population growth (in %) in Isle of Man in 2014?
Ensure brevity in your answer.  4.14. What is the difference between the Population growth (in %) of Ethiopia in 2010 and the Population growth (in %) of Oman in 2014?
Make the answer very short. -3.71. What is the difference between the Population growth (in %) of Isle of Man in 2010 and the Population growth (in %) of Oman in 2014?
Keep it short and to the point. -7.75. What is the difference between the Population growth (in %) in Latin America(all income levels) in 2011 and the Population growth (in %) in Ethiopia in 2012?
Provide a succinct answer. -3.38. What is the difference between the Population growth (in %) of Latin America(all income levels) in 2011 and the Population growth (in %) of Isle of Man in 2012?
Offer a very short reply. 0.66. What is the difference between the Population growth (in %) of Latin America(all income levels) in 2011 and the Population growth (in %) of Oman in 2012?
Your answer should be compact. -9.06. What is the difference between the Population growth (in %) in Ethiopia in 2011 and the Population growth (in %) in Isle of Man in 2012?
Provide a succinct answer. 4.07. What is the difference between the Population growth (in %) in Ethiopia in 2011 and the Population growth (in %) in Oman in 2012?
Make the answer very short. -5.64. What is the difference between the Population growth (in %) of Isle of Man in 2011 and the Population growth (in %) of Oman in 2012?
Your response must be concise. -9.7. What is the difference between the Population growth (in %) of Latin America(all income levels) in 2011 and the Population growth (in %) of Ethiopia in 2013?
Your response must be concise. -3.33. What is the difference between the Population growth (in %) of Latin America(all income levels) in 2011 and the Population growth (in %) of Isle of Man in 2013?
Your response must be concise. 0.68. What is the difference between the Population growth (in %) of Latin America(all income levels) in 2011 and the Population growth (in %) of Oman in 2013?
Make the answer very short. -8.81. What is the difference between the Population growth (in %) of Ethiopia in 2011 and the Population growth (in %) of Isle of Man in 2013?
Provide a short and direct response. 4.09. What is the difference between the Population growth (in %) of Isle of Man in 2011 and the Population growth (in %) of Oman in 2013?
Your answer should be very brief. -9.45. What is the difference between the Population growth (in %) of Latin America(all income levels) in 2011 and the Population growth (in %) of Ethiopia in 2014?
Offer a very short reply. -3.29. What is the difference between the Population growth (in %) of Latin America(all income levels) in 2011 and the Population growth (in %) of Isle of Man in 2014?
Ensure brevity in your answer.  0.68. What is the difference between the Population growth (in %) in Latin America(all income levels) in 2011 and the Population growth (in %) in Oman in 2014?
Provide a succinct answer. -7.16. What is the difference between the Population growth (in %) of Ethiopia in 2011 and the Population growth (in %) of Isle of Man in 2014?
Your response must be concise. 4.09. What is the difference between the Population growth (in %) in Ethiopia in 2011 and the Population growth (in %) in Oman in 2014?
Offer a terse response. -3.75. What is the difference between the Population growth (in %) of Isle of Man in 2011 and the Population growth (in %) of Oman in 2014?
Offer a very short reply. -7.8. What is the difference between the Population growth (in %) in Latin America(all income levels) in 2012 and the Population growth (in %) in Ethiopia in 2013?
Your answer should be very brief. -3.36. What is the difference between the Population growth (in %) in Latin America(all income levels) in 2012 and the Population growth (in %) in Isle of Man in 2013?
Ensure brevity in your answer.  0.64. What is the difference between the Population growth (in %) of Latin America(all income levels) in 2012 and the Population growth (in %) of Oman in 2013?
Provide a short and direct response. -8.85. What is the difference between the Population growth (in %) of Ethiopia in 2012 and the Population growth (in %) of Isle of Man in 2013?
Give a very brief answer. 4.06. What is the difference between the Population growth (in %) in Ethiopia in 2012 and the Population growth (in %) in Oman in 2013?
Provide a succinct answer. -5.43. What is the difference between the Population growth (in %) of Isle of Man in 2012 and the Population growth (in %) of Oman in 2013?
Your answer should be compact. -9.47. What is the difference between the Population growth (in %) in Latin America(all income levels) in 2012 and the Population growth (in %) in Ethiopia in 2014?
Keep it short and to the point. -3.32. What is the difference between the Population growth (in %) in Latin America(all income levels) in 2012 and the Population growth (in %) in Isle of Man in 2014?
Your answer should be very brief. 0.65. What is the difference between the Population growth (in %) in Latin America(all income levels) in 2012 and the Population growth (in %) in Oman in 2014?
Your response must be concise. -7.2. What is the difference between the Population growth (in %) in Ethiopia in 2012 and the Population growth (in %) in Isle of Man in 2014?
Provide a short and direct response. 4.06. What is the difference between the Population growth (in %) in Ethiopia in 2012 and the Population growth (in %) in Oman in 2014?
Provide a succinct answer. -3.78. What is the difference between the Population growth (in %) of Isle of Man in 2012 and the Population growth (in %) of Oman in 2014?
Give a very brief answer. -7.82. What is the difference between the Population growth (in %) of Latin America(all income levels) in 2013 and the Population growth (in %) of Ethiopia in 2014?
Offer a very short reply. -3.35. What is the difference between the Population growth (in %) in Latin America(all income levels) in 2013 and the Population growth (in %) in Isle of Man in 2014?
Offer a terse response. 0.61. What is the difference between the Population growth (in %) in Latin America(all income levels) in 2013 and the Population growth (in %) in Oman in 2014?
Provide a short and direct response. -7.23. What is the difference between the Population growth (in %) in Ethiopia in 2013 and the Population growth (in %) in Isle of Man in 2014?
Ensure brevity in your answer.  4.01. What is the difference between the Population growth (in %) in Ethiopia in 2013 and the Population growth (in %) in Oman in 2014?
Your answer should be very brief. -3.84. What is the difference between the Population growth (in %) of Isle of Man in 2013 and the Population growth (in %) of Oman in 2014?
Offer a terse response. -7.84. What is the average Population growth (in %) in Latin America(all income levels) per year?
Provide a succinct answer. 1.56. What is the average Population growth (in %) in Ethiopia per year?
Offer a terse response. 4.85. What is the average Population growth (in %) of Isle of Man per year?
Give a very brief answer. 0.95. What is the average Population growth (in %) of Oman per year?
Keep it short and to the point. 7.03. In the year 2007, what is the difference between the Population growth (in %) of Latin America(all income levels) and Population growth (in %) of Ethiopia?
Your answer should be compact. -2.38. In the year 2007, what is the difference between the Population growth (in %) of Latin America(all income levels) and Population growth (in %) of Isle of Man?
Ensure brevity in your answer.  0.65. In the year 2007, what is the difference between the Population growth (in %) of Latin America(all income levels) and Population growth (in %) of Oman?
Your answer should be very brief. -0.66. In the year 2007, what is the difference between the Population growth (in %) of Ethiopia and Population growth (in %) of Isle of Man?
Give a very brief answer. 3.04. In the year 2007, what is the difference between the Population growth (in %) of Ethiopia and Population growth (in %) of Oman?
Give a very brief answer. 1.72. In the year 2007, what is the difference between the Population growth (in %) of Isle of Man and Population growth (in %) of Oman?
Offer a terse response. -1.31. In the year 2008, what is the difference between the Population growth (in %) of Latin America(all income levels) and Population growth (in %) of Ethiopia?
Provide a succinct answer. -3.44. In the year 2008, what is the difference between the Population growth (in %) in Latin America(all income levels) and Population growth (in %) in Isle of Man?
Make the answer very short. 0.61. In the year 2008, what is the difference between the Population growth (in %) in Latin America(all income levels) and Population growth (in %) in Oman?
Keep it short and to the point. -1.34. In the year 2008, what is the difference between the Population growth (in %) of Ethiopia and Population growth (in %) of Isle of Man?
Keep it short and to the point. 4.05. In the year 2008, what is the difference between the Population growth (in %) of Ethiopia and Population growth (in %) of Oman?
Ensure brevity in your answer.  2.1. In the year 2008, what is the difference between the Population growth (in %) of Isle of Man and Population growth (in %) of Oman?
Give a very brief answer. -1.95. In the year 2009, what is the difference between the Population growth (in %) in Latin America(all income levels) and Population growth (in %) in Ethiopia?
Ensure brevity in your answer.  -3.42. In the year 2009, what is the difference between the Population growth (in %) of Latin America(all income levels) and Population growth (in %) of Isle of Man?
Keep it short and to the point. 0.6. In the year 2009, what is the difference between the Population growth (in %) in Latin America(all income levels) and Population growth (in %) in Oman?
Your answer should be compact. -3.17. In the year 2009, what is the difference between the Population growth (in %) in Ethiopia and Population growth (in %) in Isle of Man?
Offer a very short reply. 4.02. In the year 2009, what is the difference between the Population growth (in %) of Ethiopia and Population growth (in %) of Oman?
Offer a terse response. 0.25. In the year 2009, what is the difference between the Population growth (in %) of Isle of Man and Population growth (in %) of Oman?
Your response must be concise. -3.78. In the year 2010, what is the difference between the Population growth (in %) of Latin America(all income levels) and Population growth (in %) of Ethiopia?
Your response must be concise. -3.42. In the year 2010, what is the difference between the Population growth (in %) of Latin America(all income levels) and Population growth (in %) of Isle of Man?
Offer a terse response. 0.62. In the year 2010, what is the difference between the Population growth (in %) of Latin America(all income levels) and Population growth (in %) of Oman?
Give a very brief answer. -5.5. In the year 2010, what is the difference between the Population growth (in %) of Ethiopia and Population growth (in %) of Isle of Man?
Provide a short and direct response. 4.04. In the year 2010, what is the difference between the Population growth (in %) of Ethiopia and Population growth (in %) of Oman?
Offer a terse response. -2.08. In the year 2010, what is the difference between the Population growth (in %) of Isle of Man and Population growth (in %) of Oman?
Keep it short and to the point. -6.12. In the year 2011, what is the difference between the Population growth (in %) of Latin America(all income levels) and Population growth (in %) of Ethiopia?
Provide a succinct answer. -3.41. In the year 2011, what is the difference between the Population growth (in %) of Latin America(all income levels) and Population growth (in %) of Isle of Man?
Keep it short and to the point. 0.64. In the year 2011, what is the difference between the Population growth (in %) in Latin America(all income levels) and Population growth (in %) in Oman?
Provide a short and direct response. -7.81. In the year 2011, what is the difference between the Population growth (in %) in Ethiopia and Population growth (in %) in Isle of Man?
Your answer should be compact. 4.05. In the year 2011, what is the difference between the Population growth (in %) in Ethiopia and Population growth (in %) in Oman?
Give a very brief answer. -4.4. In the year 2011, what is the difference between the Population growth (in %) of Isle of Man and Population growth (in %) of Oman?
Provide a succinct answer. -8.45. In the year 2012, what is the difference between the Population growth (in %) of Latin America(all income levels) and Population growth (in %) of Ethiopia?
Your answer should be very brief. -3.42. In the year 2012, what is the difference between the Population growth (in %) in Latin America(all income levels) and Population growth (in %) in Isle of Man?
Give a very brief answer. 0.63. In the year 2012, what is the difference between the Population growth (in %) in Latin America(all income levels) and Population growth (in %) in Oman?
Offer a very short reply. -9.09. In the year 2012, what is the difference between the Population growth (in %) of Ethiopia and Population growth (in %) of Isle of Man?
Offer a very short reply. 4.04. In the year 2012, what is the difference between the Population growth (in %) in Ethiopia and Population growth (in %) in Oman?
Make the answer very short. -5.68. In the year 2012, what is the difference between the Population growth (in %) of Isle of Man and Population growth (in %) of Oman?
Keep it short and to the point. -9.72. In the year 2013, what is the difference between the Population growth (in %) of Latin America(all income levels) and Population growth (in %) of Ethiopia?
Your answer should be compact. -3.39. In the year 2013, what is the difference between the Population growth (in %) of Latin America(all income levels) and Population growth (in %) of Isle of Man?
Ensure brevity in your answer.  0.61. In the year 2013, what is the difference between the Population growth (in %) in Latin America(all income levels) and Population growth (in %) in Oman?
Your answer should be compact. -8.88. In the year 2013, what is the difference between the Population growth (in %) in Ethiopia and Population growth (in %) in Isle of Man?
Your response must be concise. 4. In the year 2013, what is the difference between the Population growth (in %) of Ethiopia and Population growth (in %) of Oman?
Offer a very short reply. -5.49. In the year 2013, what is the difference between the Population growth (in %) in Isle of Man and Population growth (in %) in Oman?
Provide a succinct answer. -9.49. In the year 2014, what is the difference between the Population growth (in %) of Latin America(all income levels) and Population growth (in %) of Ethiopia?
Ensure brevity in your answer.  -3.39. In the year 2014, what is the difference between the Population growth (in %) of Latin America(all income levels) and Population growth (in %) of Isle of Man?
Ensure brevity in your answer.  0.58. In the year 2014, what is the difference between the Population growth (in %) in Latin America(all income levels) and Population growth (in %) in Oman?
Provide a succinct answer. -7.27. In the year 2014, what is the difference between the Population growth (in %) in Ethiopia and Population growth (in %) in Isle of Man?
Provide a succinct answer. 3.97. In the year 2014, what is the difference between the Population growth (in %) of Ethiopia and Population growth (in %) of Oman?
Make the answer very short. -3.88. In the year 2014, what is the difference between the Population growth (in %) in Isle of Man and Population growth (in %) in Oman?
Offer a terse response. -7.84. What is the ratio of the Population growth (in %) in Latin America(all income levels) in 2007 to that in 2008?
Keep it short and to the point. 1.02. What is the ratio of the Population growth (in %) in Ethiopia in 2007 to that in 2008?
Give a very brief answer. 0.8. What is the ratio of the Population growth (in %) of Isle of Man in 2007 to that in 2008?
Provide a short and direct response. 0.99. What is the ratio of the Population growth (in %) in Oman in 2007 to that in 2008?
Offer a very short reply. 0.78. What is the ratio of the Population growth (in %) of Latin America(all income levels) in 2007 to that in 2009?
Give a very brief answer. 1.04. What is the ratio of the Population growth (in %) in Ethiopia in 2007 to that in 2009?
Your answer should be very brief. 0.81. What is the ratio of the Population growth (in %) in Oman in 2007 to that in 2009?
Provide a short and direct response. 0.49. What is the ratio of the Population growth (in %) of Latin America(all income levels) in 2007 to that in 2010?
Keep it short and to the point. 1.06. What is the ratio of the Population growth (in %) in Ethiopia in 2007 to that in 2010?
Make the answer very short. 0.81. What is the ratio of the Population growth (in %) of Isle of Man in 2007 to that in 2010?
Ensure brevity in your answer.  1.06. What is the ratio of the Population growth (in %) of Oman in 2007 to that in 2010?
Give a very brief answer. 0.33. What is the ratio of the Population growth (in %) of Latin America(all income levels) in 2007 to that in 2011?
Your answer should be very brief. 1.08. What is the ratio of the Population growth (in %) of Ethiopia in 2007 to that in 2011?
Your answer should be compact. 0.82. What is the ratio of the Population growth (in %) of Isle of Man in 2007 to that in 2011?
Keep it short and to the point. 1.12. What is the ratio of the Population growth (in %) of Oman in 2007 to that in 2011?
Provide a short and direct response. 0.25. What is the ratio of the Population growth (in %) of Latin America(all income levels) in 2007 to that in 2012?
Offer a terse response. 1.1. What is the ratio of the Population growth (in %) of Ethiopia in 2007 to that in 2012?
Your answer should be very brief. 0.82. What is the ratio of the Population growth (in %) in Isle of Man in 2007 to that in 2012?
Your answer should be very brief. 1.15. What is the ratio of the Population growth (in %) in Oman in 2007 to that in 2012?
Provide a succinct answer. 0.22. What is the ratio of the Population growth (in %) in Latin America(all income levels) in 2007 to that in 2013?
Offer a terse response. 1.13. What is the ratio of the Population growth (in %) in Ethiopia in 2007 to that in 2013?
Your answer should be very brief. 0.83. What is the ratio of the Population growth (in %) of Isle of Man in 2007 to that in 2013?
Provide a succinct answer. 1.17. What is the ratio of the Population growth (in %) of Oman in 2007 to that in 2013?
Your answer should be very brief. 0.23. What is the ratio of the Population growth (in %) of Latin America(all income levels) in 2007 to that in 2014?
Ensure brevity in your answer.  1.16. What is the ratio of the Population growth (in %) of Ethiopia in 2007 to that in 2014?
Your answer should be very brief. 0.84. What is the ratio of the Population growth (in %) in Isle of Man in 2007 to that in 2014?
Provide a succinct answer. 1.17. What is the ratio of the Population growth (in %) in Oman in 2007 to that in 2014?
Offer a very short reply. 0.27. What is the ratio of the Population growth (in %) of Latin America(all income levels) in 2008 to that in 2009?
Make the answer very short. 1.02. What is the ratio of the Population growth (in %) of Ethiopia in 2008 to that in 2009?
Offer a very short reply. 1.01. What is the ratio of the Population growth (in %) of Isle of Man in 2008 to that in 2009?
Offer a terse response. 1.02. What is the ratio of the Population growth (in %) in Oman in 2008 to that in 2009?
Provide a succinct answer. 0.62. What is the ratio of the Population growth (in %) in Latin America(all income levels) in 2008 to that in 2010?
Keep it short and to the point. 1.04. What is the ratio of the Population growth (in %) of Ethiopia in 2008 to that in 2010?
Your answer should be compact. 1.02. What is the ratio of the Population growth (in %) in Isle of Man in 2008 to that in 2010?
Keep it short and to the point. 1.07. What is the ratio of the Population growth (in %) in Oman in 2008 to that in 2010?
Your response must be concise. 0.42. What is the ratio of the Population growth (in %) in Latin America(all income levels) in 2008 to that in 2011?
Your answer should be compact. 1.06. What is the ratio of the Population growth (in %) of Ethiopia in 2008 to that in 2011?
Your answer should be very brief. 1.02. What is the ratio of the Population growth (in %) of Isle of Man in 2008 to that in 2011?
Ensure brevity in your answer.  1.14. What is the ratio of the Population growth (in %) of Oman in 2008 to that in 2011?
Ensure brevity in your answer.  0.32. What is the ratio of the Population growth (in %) of Latin America(all income levels) in 2008 to that in 2012?
Make the answer very short. 1.09. What is the ratio of the Population growth (in %) in Ethiopia in 2008 to that in 2012?
Offer a terse response. 1.03. What is the ratio of the Population growth (in %) in Isle of Man in 2008 to that in 2012?
Provide a succinct answer. 1.16. What is the ratio of the Population growth (in %) in Oman in 2008 to that in 2012?
Offer a very short reply. 0.28. What is the ratio of the Population growth (in %) in Latin America(all income levels) in 2008 to that in 2013?
Provide a succinct answer. 1.11. What is the ratio of the Population growth (in %) in Ethiopia in 2008 to that in 2013?
Your answer should be very brief. 1.04. What is the ratio of the Population growth (in %) in Isle of Man in 2008 to that in 2013?
Your answer should be very brief. 1.18. What is the ratio of the Population growth (in %) in Oman in 2008 to that in 2013?
Your answer should be very brief. 0.29. What is the ratio of the Population growth (in %) of Latin America(all income levels) in 2008 to that in 2014?
Keep it short and to the point. 1.14. What is the ratio of the Population growth (in %) of Ethiopia in 2008 to that in 2014?
Keep it short and to the point. 1.05. What is the ratio of the Population growth (in %) of Isle of Man in 2008 to that in 2014?
Provide a succinct answer. 1.19. What is the ratio of the Population growth (in %) of Oman in 2008 to that in 2014?
Offer a very short reply. 0.34. What is the ratio of the Population growth (in %) in Latin America(all income levels) in 2009 to that in 2010?
Give a very brief answer. 1.02. What is the ratio of the Population growth (in %) of Ethiopia in 2009 to that in 2010?
Keep it short and to the point. 1.01. What is the ratio of the Population growth (in %) of Isle of Man in 2009 to that in 2010?
Your answer should be compact. 1.05. What is the ratio of the Population growth (in %) in Oman in 2009 to that in 2010?
Provide a short and direct response. 0.68. What is the ratio of the Population growth (in %) in Latin America(all income levels) in 2009 to that in 2011?
Ensure brevity in your answer.  1.04. What is the ratio of the Population growth (in %) in Ethiopia in 2009 to that in 2011?
Your response must be concise. 1.01. What is the ratio of the Population growth (in %) in Isle of Man in 2009 to that in 2011?
Your answer should be compact. 1.11. What is the ratio of the Population growth (in %) in Oman in 2009 to that in 2011?
Your response must be concise. 0.51. What is the ratio of the Population growth (in %) of Latin America(all income levels) in 2009 to that in 2012?
Your answer should be compact. 1.06. What is the ratio of the Population growth (in %) of Ethiopia in 2009 to that in 2012?
Provide a short and direct response. 1.02. What is the ratio of the Population growth (in %) of Isle of Man in 2009 to that in 2012?
Offer a very short reply. 1.14. What is the ratio of the Population growth (in %) in Oman in 2009 to that in 2012?
Your response must be concise. 0.45. What is the ratio of the Population growth (in %) of Latin America(all income levels) in 2009 to that in 2013?
Ensure brevity in your answer.  1.09. What is the ratio of the Population growth (in %) of Ethiopia in 2009 to that in 2013?
Your answer should be very brief. 1.03. What is the ratio of the Population growth (in %) in Isle of Man in 2009 to that in 2013?
Your answer should be very brief. 1.16. What is the ratio of the Population growth (in %) in Oman in 2009 to that in 2013?
Make the answer very short. 0.46. What is the ratio of the Population growth (in %) in Latin America(all income levels) in 2009 to that in 2014?
Offer a terse response. 1.12. What is the ratio of the Population growth (in %) of Ethiopia in 2009 to that in 2014?
Offer a very short reply. 1.04. What is the ratio of the Population growth (in %) in Isle of Man in 2009 to that in 2014?
Offer a very short reply. 1.16. What is the ratio of the Population growth (in %) in Oman in 2009 to that in 2014?
Keep it short and to the point. 0.55. What is the ratio of the Population growth (in %) in Latin America(all income levels) in 2010 to that in 2011?
Provide a short and direct response. 1.02. What is the ratio of the Population growth (in %) of Ethiopia in 2010 to that in 2011?
Give a very brief answer. 1.01. What is the ratio of the Population growth (in %) in Isle of Man in 2010 to that in 2011?
Keep it short and to the point. 1.06. What is the ratio of the Population growth (in %) of Oman in 2010 to that in 2011?
Your answer should be very brief. 0.76. What is the ratio of the Population growth (in %) of Latin America(all income levels) in 2010 to that in 2012?
Offer a terse response. 1.04. What is the ratio of the Population growth (in %) of Ethiopia in 2010 to that in 2012?
Make the answer very short. 1.01. What is the ratio of the Population growth (in %) of Isle of Man in 2010 to that in 2012?
Offer a terse response. 1.08. What is the ratio of the Population growth (in %) in Oman in 2010 to that in 2012?
Keep it short and to the point. 0.67. What is the ratio of the Population growth (in %) of Latin America(all income levels) in 2010 to that in 2013?
Give a very brief answer. 1.07. What is the ratio of the Population growth (in %) of Ethiopia in 2010 to that in 2013?
Your answer should be very brief. 1.03. What is the ratio of the Population growth (in %) in Isle of Man in 2010 to that in 2013?
Your response must be concise. 1.1. What is the ratio of the Population growth (in %) in Oman in 2010 to that in 2013?
Give a very brief answer. 0.68. What is the ratio of the Population growth (in %) of Latin America(all income levels) in 2010 to that in 2014?
Your answer should be compact. 1.1. What is the ratio of the Population growth (in %) of Ethiopia in 2010 to that in 2014?
Provide a succinct answer. 1.03. What is the ratio of the Population growth (in %) in Isle of Man in 2010 to that in 2014?
Your response must be concise. 1.11. What is the ratio of the Population growth (in %) of Oman in 2010 to that in 2014?
Offer a very short reply. 0.81. What is the ratio of the Population growth (in %) in Latin America(all income levels) in 2011 to that in 2012?
Make the answer very short. 1.02. What is the ratio of the Population growth (in %) of Ethiopia in 2011 to that in 2012?
Keep it short and to the point. 1.01. What is the ratio of the Population growth (in %) of Isle of Man in 2011 to that in 2012?
Your answer should be very brief. 1.02. What is the ratio of the Population growth (in %) in Oman in 2011 to that in 2012?
Your response must be concise. 0.88. What is the ratio of the Population growth (in %) of Latin America(all income levels) in 2011 to that in 2013?
Your response must be concise. 1.05. What is the ratio of the Population growth (in %) in Ethiopia in 2011 to that in 2013?
Your answer should be compact. 1.02. What is the ratio of the Population growth (in %) in Isle of Man in 2011 to that in 2013?
Your answer should be very brief. 1.04. What is the ratio of the Population growth (in %) in Oman in 2011 to that in 2013?
Provide a short and direct response. 0.9. What is the ratio of the Population growth (in %) of Latin America(all income levels) in 2011 to that in 2014?
Keep it short and to the point. 1.07. What is the ratio of the Population growth (in %) in Ethiopia in 2011 to that in 2014?
Your answer should be compact. 1.03. What is the ratio of the Population growth (in %) of Isle of Man in 2011 to that in 2014?
Your answer should be compact. 1.05. What is the ratio of the Population growth (in %) of Oman in 2011 to that in 2014?
Provide a succinct answer. 1.07. What is the ratio of the Population growth (in %) in Latin America(all income levels) in 2012 to that in 2013?
Keep it short and to the point. 1.02. What is the ratio of the Population growth (in %) in Ethiopia in 2012 to that in 2013?
Offer a very short reply. 1.01. What is the ratio of the Population growth (in %) in Isle of Man in 2012 to that in 2013?
Ensure brevity in your answer.  1.02. What is the ratio of the Population growth (in %) of Oman in 2012 to that in 2013?
Provide a succinct answer. 1.02. What is the ratio of the Population growth (in %) in Latin America(all income levels) in 2012 to that in 2014?
Your answer should be compact. 1.05. What is the ratio of the Population growth (in %) of Ethiopia in 2012 to that in 2014?
Offer a very short reply. 1.02. What is the ratio of the Population growth (in %) in Isle of Man in 2012 to that in 2014?
Give a very brief answer. 1.02. What is the ratio of the Population growth (in %) of Oman in 2012 to that in 2014?
Ensure brevity in your answer.  1.22. What is the ratio of the Population growth (in %) in Latin America(all income levels) in 2013 to that in 2014?
Offer a very short reply. 1.02. What is the ratio of the Population growth (in %) of Ethiopia in 2013 to that in 2014?
Offer a very short reply. 1.01. What is the ratio of the Population growth (in %) of Isle of Man in 2013 to that in 2014?
Your answer should be compact. 1.01. What is the ratio of the Population growth (in %) of Oman in 2013 to that in 2014?
Give a very brief answer. 1.19. What is the difference between the highest and the second highest Population growth (in %) of Latin America(all income levels)?
Keep it short and to the point. 0.03. What is the difference between the highest and the second highest Population growth (in %) in Ethiopia?
Provide a succinct answer. 0.05. What is the difference between the highest and the second highest Population growth (in %) in Isle of Man?
Your response must be concise. 0.01. What is the difference between the highest and the second highest Population growth (in %) of Oman?
Offer a terse response. 0.24. What is the difference between the highest and the lowest Population growth (in %) in Latin America(all income levels)?
Your response must be concise. 0.23. What is the difference between the highest and the lowest Population growth (in %) of Ethiopia?
Offer a very short reply. 1.03. What is the difference between the highest and the lowest Population growth (in %) in Isle of Man?
Your answer should be very brief. 0.16. What is the difference between the highest and the lowest Population growth (in %) of Oman?
Your answer should be very brief. 8.27. 